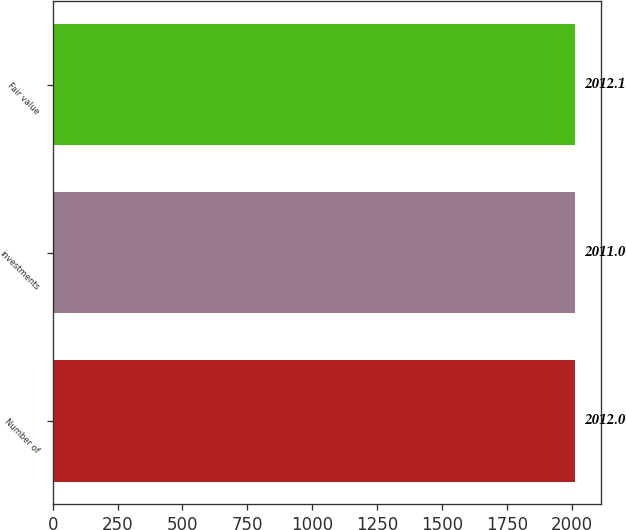<chart> <loc_0><loc_0><loc_500><loc_500><bar_chart><fcel>Number of<fcel>investments<fcel>Fair value<nl><fcel>2012<fcel>2011<fcel>2012.1<nl></chart> 